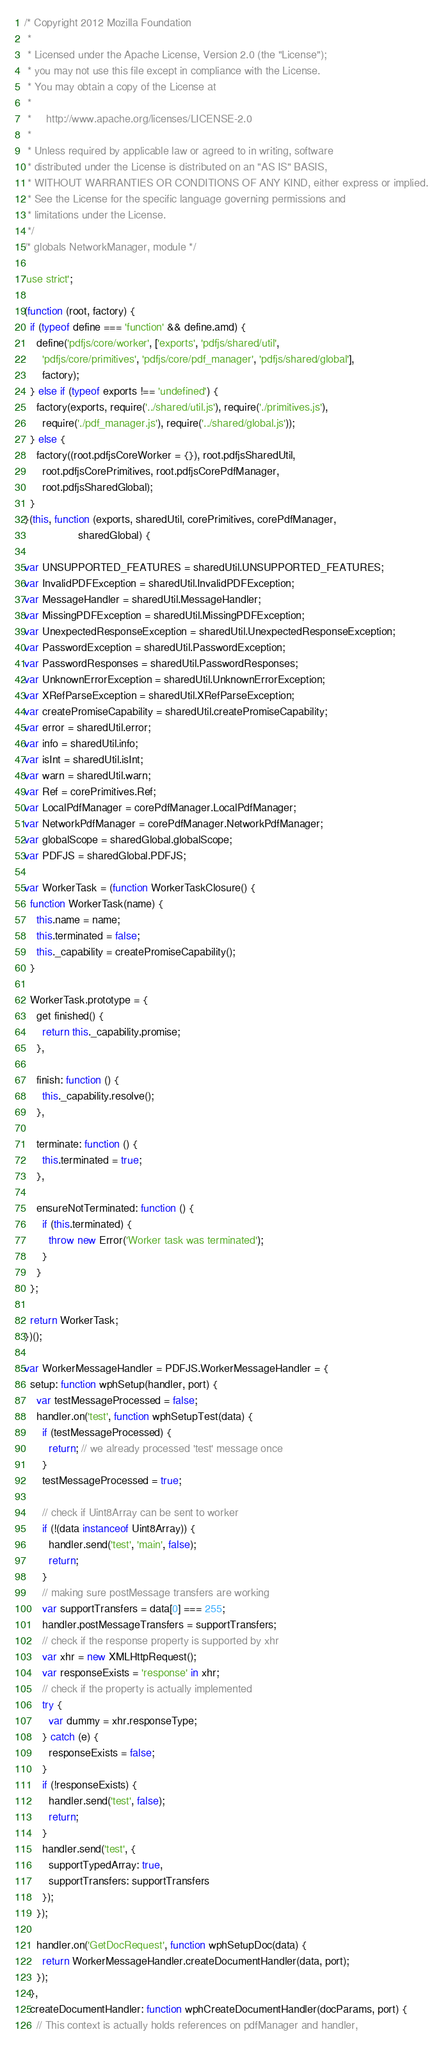<code> <loc_0><loc_0><loc_500><loc_500><_JavaScript_>/* Copyright 2012 Mozilla Foundation
 *
 * Licensed under the Apache License, Version 2.0 (the "License");
 * you may not use this file except in compliance with the License.
 * You may obtain a copy of the License at
 *
 *     http://www.apache.org/licenses/LICENSE-2.0
 *
 * Unless required by applicable law or agreed to in writing, software
 * distributed under the License is distributed on an "AS IS" BASIS,
 * WITHOUT WARRANTIES OR CONDITIONS OF ANY KIND, either express or implied.
 * See the License for the specific language governing permissions and
 * limitations under the License.
 */
/* globals NetworkManager, module */

'use strict';

(function (root, factory) {
  if (typeof define === 'function' && define.amd) {
    define('pdfjs/core/worker', ['exports', 'pdfjs/shared/util',
      'pdfjs/core/primitives', 'pdfjs/core/pdf_manager', 'pdfjs/shared/global'],
      factory);
  } else if (typeof exports !== 'undefined') {
    factory(exports, require('../shared/util.js'), require('./primitives.js'),
      require('./pdf_manager.js'), require('../shared/global.js'));
  } else {
    factory((root.pdfjsCoreWorker = {}), root.pdfjsSharedUtil,
      root.pdfjsCorePrimitives, root.pdfjsCorePdfManager,
      root.pdfjsSharedGlobal);
  }
}(this, function (exports, sharedUtil, corePrimitives, corePdfManager,
                  sharedGlobal) {

var UNSUPPORTED_FEATURES = sharedUtil.UNSUPPORTED_FEATURES;
var InvalidPDFException = sharedUtil.InvalidPDFException;
var MessageHandler = sharedUtil.MessageHandler;
var MissingPDFException = sharedUtil.MissingPDFException;
var UnexpectedResponseException = sharedUtil.UnexpectedResponseException;
var PasswordException = sharedUtil.PasswordException;
var PasswordResponses = sharedUtil.PasswordResponses;
var UnknownErrorException = sharedUtil.UnknownErrorException;
var XRefParseException = sharedUtil.XRefParseException;
var createPromiseCapability = sharedUtil.createPromiseCapability;
var error = sharedUtil.error;
var info = sharedUtil.info;
var isInt = sharedUtil.isInt;
var warn = sharedUtil.warn;
var Ref = corePrimitives.Ref;
var LocalPdfManager = corePdfManager.LocalPdfManager;
var NetworkPdfManager = corePdfManager.NetworkPdfManager;
var globalScope = sharedGlobal.globalScope;
var PDFJS = sharedGlobal.PDFJS;

var WorkerTask = (function WorkerTaskClosure() {
  function WorkerTask(name) {
    this.name = name;
    this.terminated = false;
    this._capability = createPromiseCapability();
  }

  WorkerTask.prototype = {
    get finished() {
      return this._capability.promise;
    },

    finish: function () {
      this._capability.resolve();
    },

    terminate: function () {
      this.terminated = true;
    },

    ensureNotTerminated: function () {
      if (this.terminated) {
        throw new Error('Worker task was terminated');
      }
    }
  };

  return WorkerTask;
})();

var WorkerMessageHandler = PDFJS.WorkerMessageHandler = {
  setup: function wphSetup(handler, port) {
    var testMessageProcessed = false;
    handler.on('test', function wphSetupTest(data) {
      if (testMessageProcessed) {
        return; // we already processed 'test' message once
      }
      testMessageProcessed = true;

      // check if Uint8Array can be sent to worker
      if (!(data instanceof Uint8Array)) {
        handler.send('test', 'main', false);
        return;
      }
      // making sure postMessage transfers are working
      var supportTransfers = data[0] === 255;
      handler.postMessageTransfers = supportTransfers;
      // check if the response property is supported by xhr
      var xhr = new XMLHttpRequest();
      var responseExists = 'response' in xhr;
      // check if the property is actually implemented
      try {
        var dummy = xhr.responseType;
      } catch (e) {
        responseExists = false;
      }
      if (!responseExists) {
        handler.send('test', false);
        return;
      }
      handler.send('test', {
        supportTypedArray: true,
        supportTransfers: supportTransfers
      });
    });

    handler.on('GetDocRequest', function wphSetupDoc(data) {
      return WorkerMessageHandler.createDocumentHandler(data, port);
    });
  },
  createDocumentHandler: function wphCreateDocumentHandler(docParams, port) {
    // This context is actually holds references on pdfManager and handler,</code> 